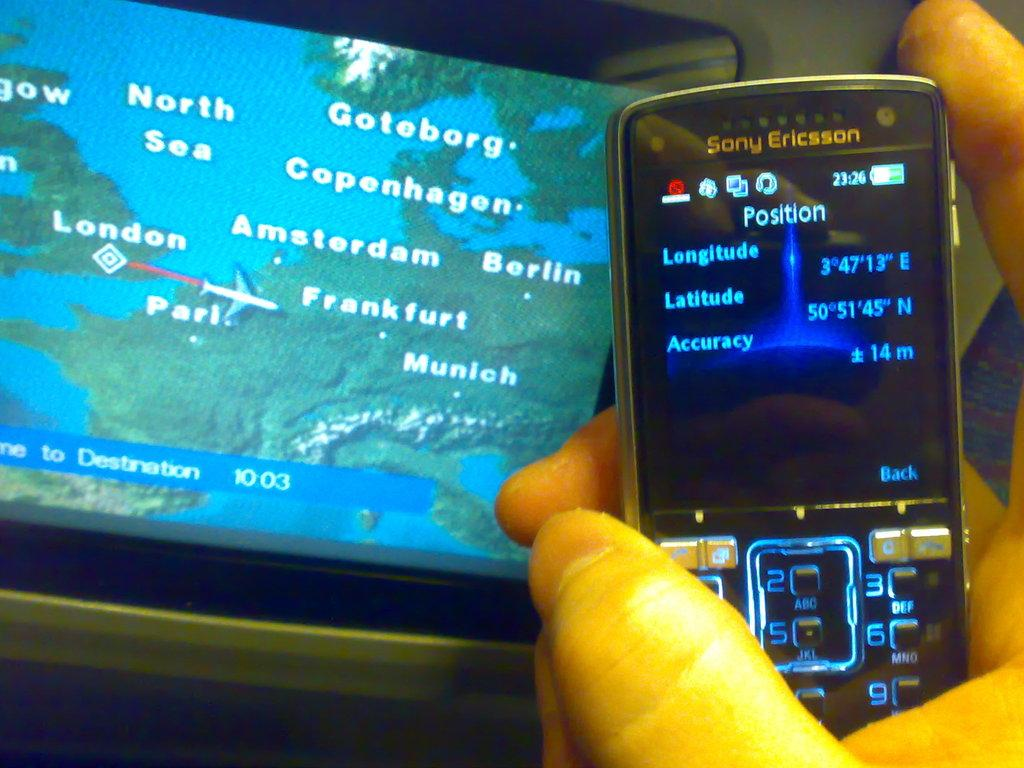<image>
Offer a succinct explanation of the picture presented. A phone in front of a screen on a seat back showing a map of Europe with countries labeled. 